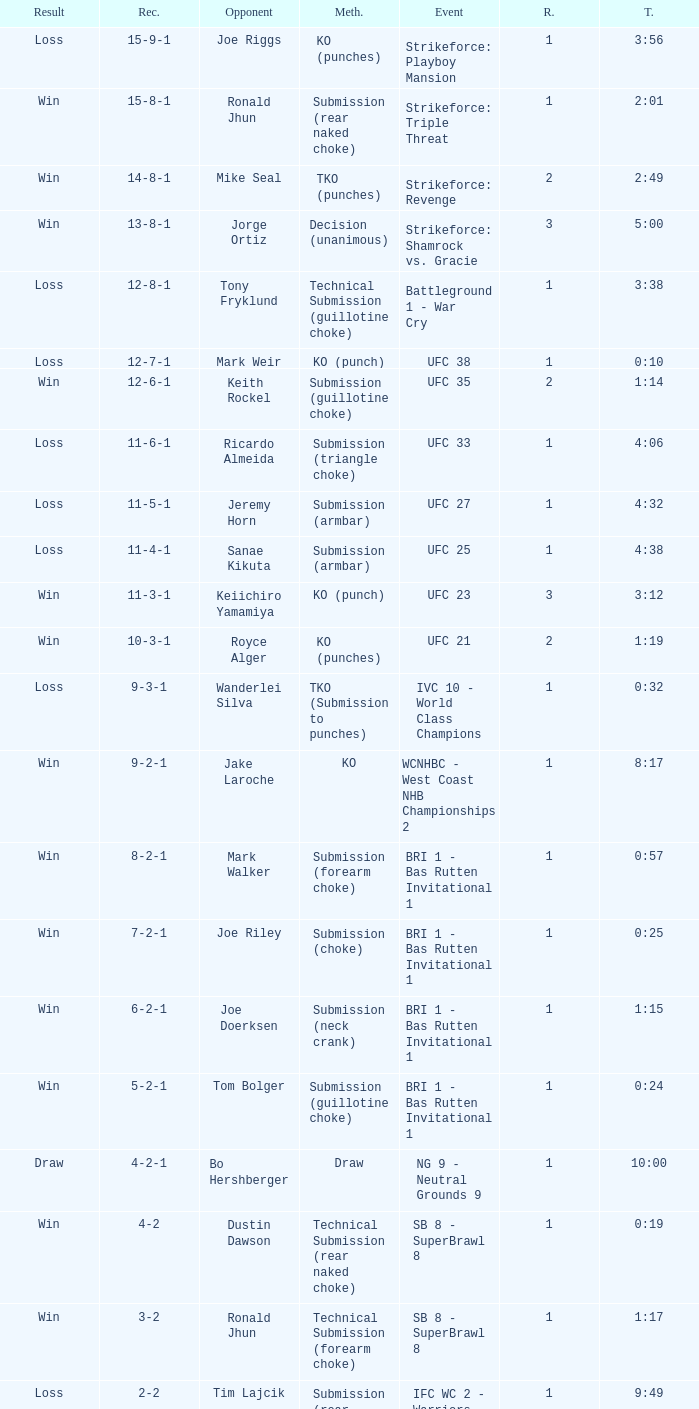What was the score when the technique of resolution was knockout? 9-2-1. 